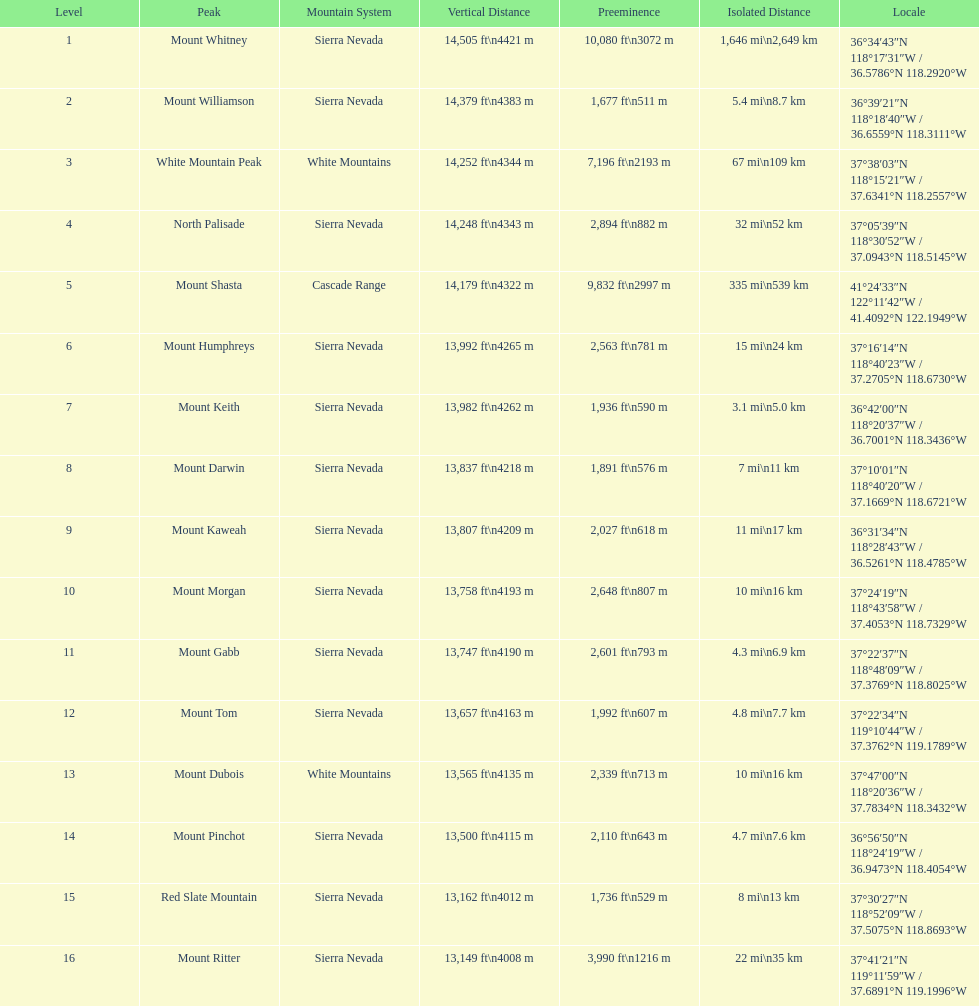Which mountain pinnacle doesn't surpass 13,149 ft? Mount Ritter. 